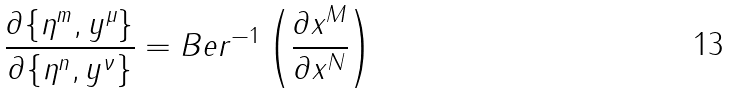<formula> <loc_0><loc_0><loc_500><loc_500>\frac { \partial \{ \eta ^ { m } , y ^ { \mu } \} } { \partial \{ \eta ^ { n } , y ^ { \nu } \} } = B e r ^ { - 1 } \left ( \frac { \partial x ^ { M } } { \partial x ^ { N } } \right )</formula> 